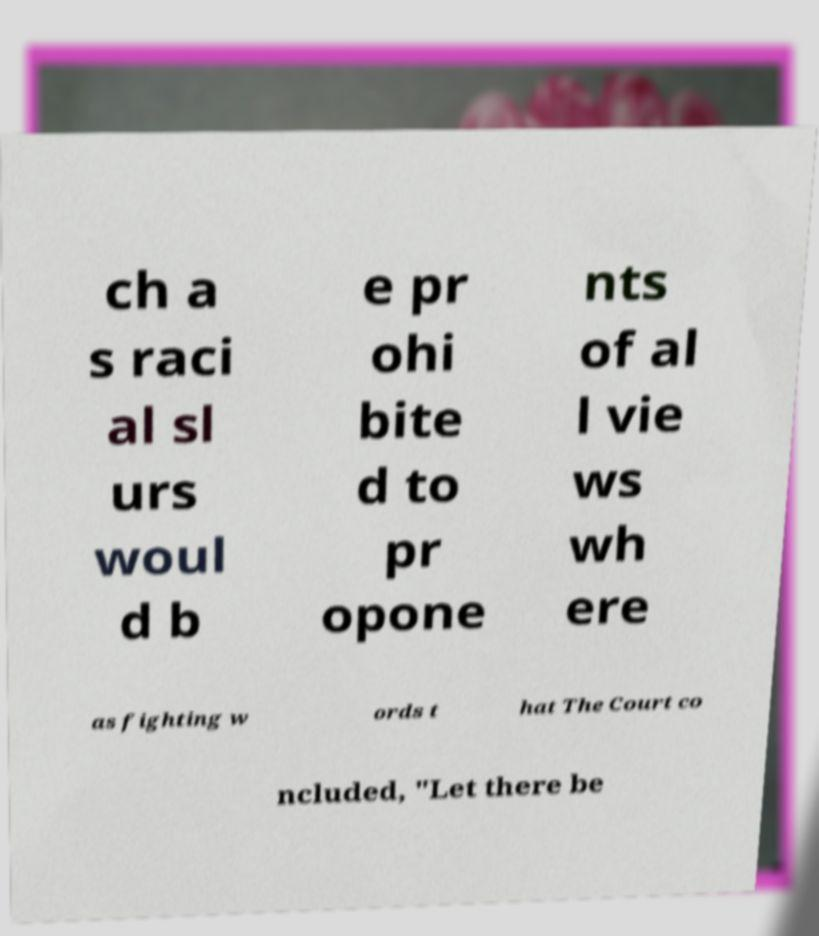Could you assist in decoding the text presented in this image and type it out clearly? ch a s raci al sl urs woul d b e pr ohi bite d to pr opone nts of al l vie ws wh ere as fighting w ords t hat The Court co ncluded, "Let there be 